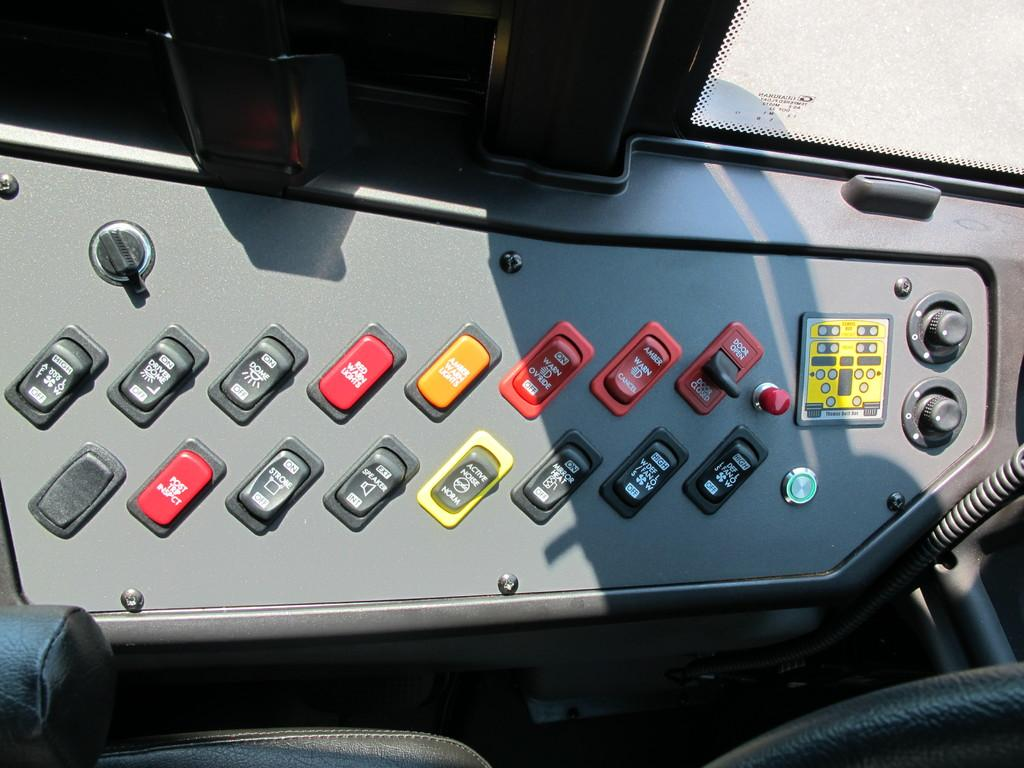What is the main subject of the picture? The main subject of the picture is a bus control panel. What can be found on the control panel? The control panel has different buttons. What colors are the buttons on the control panel? The buttons are in red and yellow colors. What type of flesh can be seen on the control panel in the image? There is no flesh present on the control panel in the image; it is a panel with buttons in red and yellow colors. 